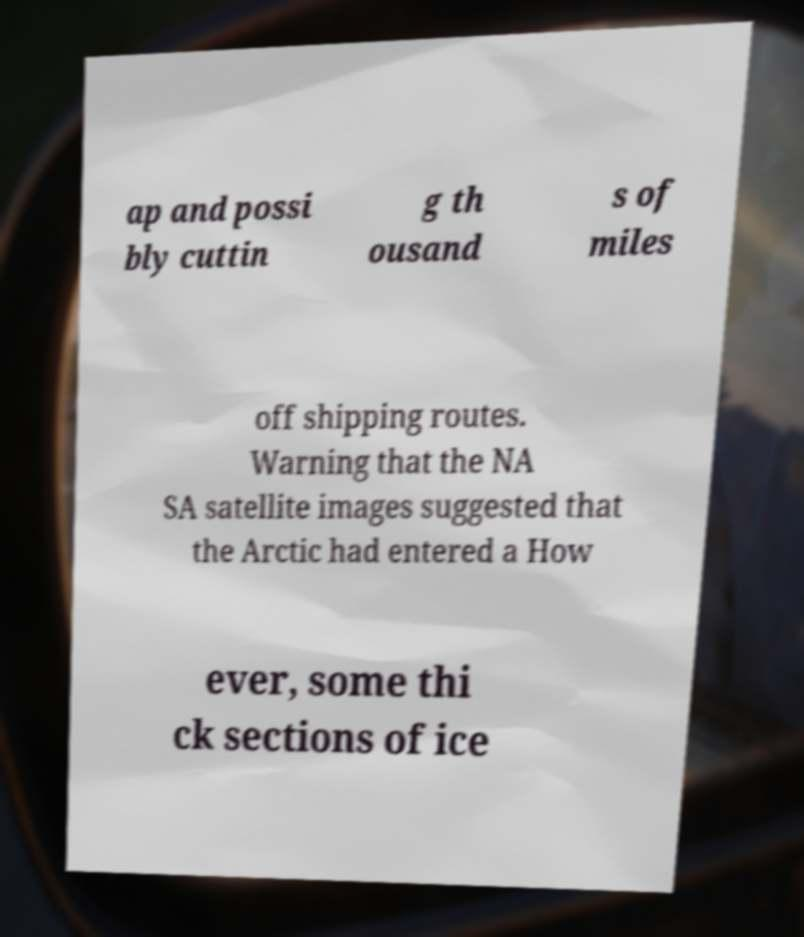Could you assist in decoding the text presented in this image and type it out clearly? ap and possi bly cuttin g th ousand s of miles off shipping routes. Warning that the NA SA satellite images suggested that the Arctic had entered a How ever, some thi ck sections of ice 